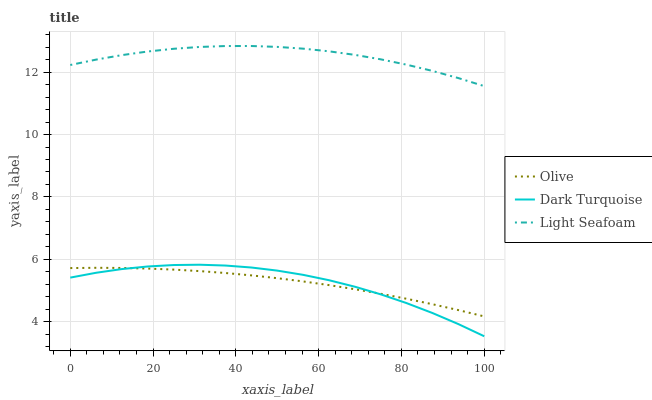Does Olive have the minimum area under the curve?
Answer yes or no. Yes. Does Light Seafoam have the maximum area under the curve?
Answer yes or no. Yes. Does Dark Turquoise have the minimum area under the curve?
Answer yes or no. No. Does Dark Turquoise have the maximum area under the curve?
Answer yes or no. No. Is Olive the smoothest?
Answer yes or no. Yes. Is Dark Turquoise the roughest?
Answer yes or no. Yes. Is Light Seafoam the smoothest?
Answer yes or no. No. Is Light Seafoam the roughest?
Answer yes or no. No. Does Dark Turquoise have the lowest value?
Answer yes or no. Yes. Does Light Seafoam have the lowest value?
Answer yes or no. No. Does Light Seafoam have the highest value?
Answer yes or no. Yes. Does Dark Turquoise have the highest value?
Answer yes or no. No. Is Olive less than Light Seafoam?
Answer yes or no. Yes. Is Light Seafoam greater than Olive?
Answer yes or no. Yes. Does Dark Turquoise intersect Olive?
Answer yes or no. Yes. Is Dark Turquoise less than Olive?
Answer yes or no. No. Is Dark Turquoise greater than Olive?
Answer yes or no. No. Does Olive intersect Light Seafoam?
Answer yes or no. No. 